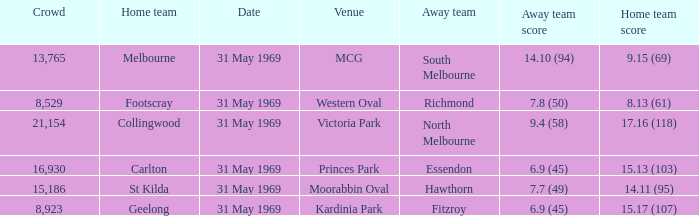Which domestic team tallied 1 St Kilda. 